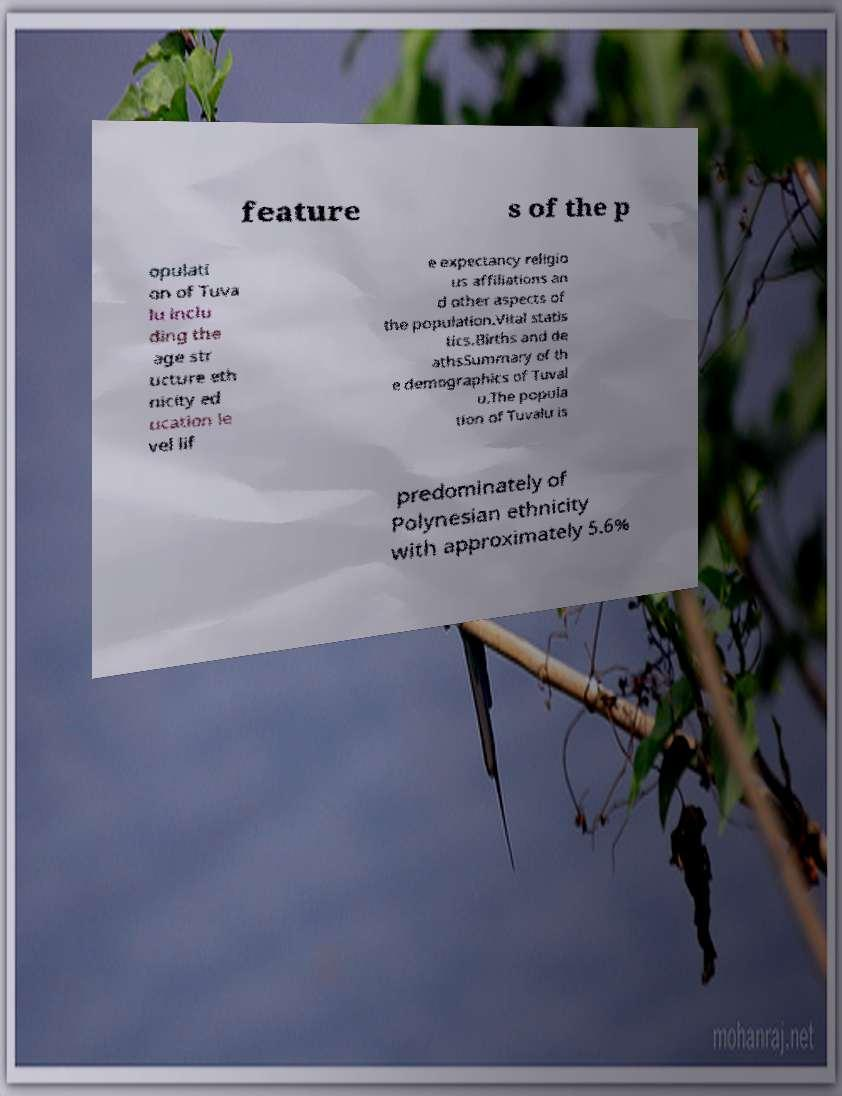Please read and relay the text visible in this image. What does it say? feature s of the p opulati on of Tuva lu inclu ding the age str ucture eth nicity ed ucation le vel lif e expectancy religio us affiliations an d other aspects of the population.Vital statis tics.Births and de athsSummary of th e demographics of Tuval u.The popula tion of Tuvalu is predominately of Polynesian ethnicity with approximately 5.6% 